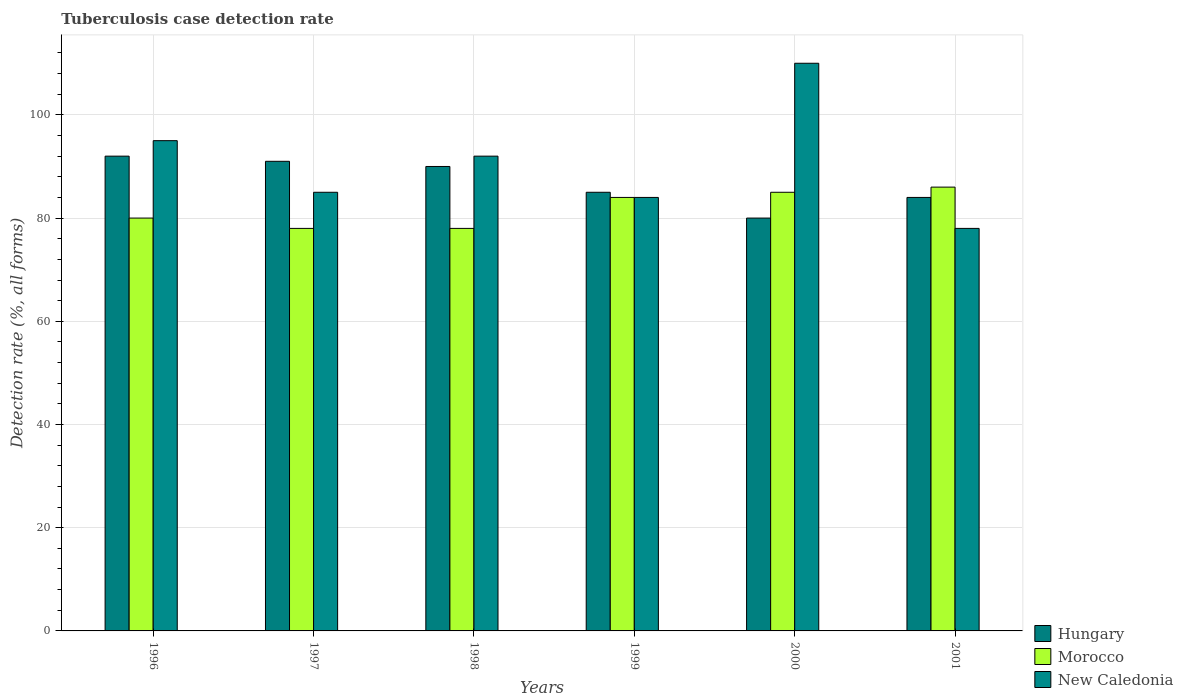How many groups of bars are there?
Make the answer very short. 6. Are the number of bars per tick equal to the number of legend labels?
Keep it short and to the point. Yes. How many bars are there on the 2nd tick from the left?
Provide a short and direct response. 3. What is the tuberculosis case detection rate in in Hungary in 1999?
Provide a short and direct response. 85. Across all years, what is the maximum tuberculosis case detection rate in in Hungary?
Your response must be concise. 92. Across all years, what is the minimum tuberculosis case detection rate in in Hungary?
Offer a very short reply. 80. What is the total tuberculosis case detection rate in in Morocco in the graph?
Your answer should be compact. 491. What is the difference between the tuberculosis case detection rate in in Hungary in 1996 and that in 1997?
Provide a short and direct response. 1. What is the average tuberculosis case detection rate in in Morocco per year?
Offer a very short reply. 81.83. In how many years, is the tuberculosis case detection rate in in Morocco greater than 64 %?
Your answer should be very brief. 6. What is the ratio of the tuberculosis case detection rate in in Morocco in 1998 to that in 2001?
Your answer should be compact. 0.91. Is the difference between the tuberculosis case detection rate in in New Caledonia in 1997 and 2000 greater than the difference between the tuberculosis case detection rate in in Hungary in 1997 and 2000?
Offer a terse response. No. What is the difference between the highest and the lowest tuberculosis case detection rate in in Morocco?
Provide a short and direct response. 8. In how many years, is the tuberculosis case detection rate in in Hungary greater than the average tuberculosis case detection rate in in Hungary taken over all years?
Provide a short and direct response. 3. Is the sum of the tuberculosis case detection rate in in Morocco in 1997 and 2000 greater than the maximum tuberculosis case detection rate in in New Caledonia across all years?
Your answer should be very brief. Yes. What does the 3rd bar from the left in 1996 represents?
Provide a short and direct response. New Caledonia. What does the 1st bar from the right in 1998 represents?
Offer a very short reply. New Caledonia. Are all the bars in the graph horizontal?
Provide a short and direct response. No. How many years are there in the graph?
Your response must be concise. 6. Does the graph contain any zero values?
Ensure brevity in your answer.  No. Where does the legend appear in the graph?
Give a very brief answer. Bottom right. How many legend labels are there?
Provide a succinct answer. 3. How are the legend labels stacked?
Keep it short and to the point. Vertical. What is the title of the graph?
Ensure brevity in your answer.  Tuberculosis case detection rate. What is the label or title of the Y-axis?
Keep it short and to the point. Detection rate (%, all forms). What is the Detection rate (%, all forms) in Hungary in 1996?
Your answer should be very brief. 92. What is the Detection rate (%, all forms) in New Caledonia in 1996?
Ensure brevity in your answer.  95. What is the Detection rate (%, all forms) of Hungary in 1997?
Offer a very short reply. 91. What is the Detection rate (%, all forms) in Morocco in 1997?
Offer a terse response. 78. What is the Detection rate (%, all forms) of New Caledonia in 1997?
Offer a terse response. 85. What is the Detection rate (%, all forms) of Hungary in 1998?
Ensure brevity in your answer.  90. What is the Detection rate (%, all forms) in Morocco in 1998?
Keep it short and to the point. 78. What is the Detection rate (%, all forms) in New Caledonia in 1998?
Your response must be concise. 92. What is the Detection rate (%, all forms) of Hungary in 1999?
Keep it short and to the point. 85. What is the Detection rate (%, all forms) of Morocco in 1999?
Offer a terse response. 84. What is the Detection rate (%, all forms) in New Caledonia in 1999?
Your answer should be very brief. 84. What is the Detection rate (%, all forms) of New Caledonia in 2000?
Make the answer very short. 110. What is the Detection rate (%, all forms) in Hungary in 2001?
Provide a short and direct response. 84. What is the Detection rate (%, all forms) in Morocco in 2001?
Offer a terse response. 86. Across all years, what is the maximum Detection rate (%, all forms) in Hungary?
Your answer should be compact. 92. Across all years, what is the maximum Detection rate (%, all forms) of Morocco?
Keep it short and to the point. 86. Across all years, what is the maximum Detection rate (%, all forms) in New Caledonia?
Make the answer very short. 110. Across all years, what is the minimum Detection rate (%, all forms) of Hungary?
Your answer should be very brief. 80. What is the total Detection rate (%, all forms) of Hungary in the graph?
Your answer should be compact. 522. What is the total Detection rate (%, all forms) of Morocco in the graph?
Your answer should be very brief. 491. What is the total Detection rate (%, all forms) of New Caledonia in the graph?
Keep it short and to the point. 544. What is the difference between the Detection rate (%, all forms) of Hungary in 1996 and that in 1997?
Offer a very short reply. 1. What is the difference between the Detection rate (%, all forms) of New Caledonia in 1996 and that in 1997?
Provide a short and direct response. 10. What is the difference between the Detection rate (%, all forms) in New Caledonia in 1996 and that in 1998?
Provide a short and direct response. 3. What is the difference between the Detection rate (%, all forms) in Morocco in 1996 and that in 1999?
Offer a very short reply. -4. What is the difference between the Detection rate (%, all forms) in New Caledonia in 1996 and that in 1999?
Your answer should be compact. 11. What is the difference between the Detection rate (%, all forms) in New Caledonia in 1996 and that in 2000?
Offer a terse response. -15. What is the difference between the Detection rate (%, all forms) in Hungary in 1996 and that in 2001?
Your response must be concise. 8. What is the difference between the Detection rate (%, all forms) in Morocco in 1996 and that in 2001?
Ensure brevity in your answer.  -6. What is the difference between the Detection rate (%, all forms) of New Caledonia in 1997 and that in 1998?
Your answer should be very brief. -7. What is the difference between the Detection rate (%, all forms) in Morocco in 1997 and that in 1999?
Keep it short and to the point. -6. What is the difference between the Detection rate (%, all forms) in New Caledonia in 1997 and that in 1999?
Offer a very short reply. 1. What is the difference between the Detection rate (%, all forms) of Hungary in 1997 and that in 2001?
Keep it short and to the point. 7. What is the difference between the Detection rate (%, all forms) in Morocco in 1998 and that in 1999?
Offer a terse response. -6. What is the difference between the Detection rate (%, all forms) in Hungary in 1998 and that in 2000?
Your answer should be very brief. 10. What is the difference between the Detection rate (%, all forms) of New Caledonia in 1998 and that in 2000?
Provide a short and direct response. -18. What is the difference between the Detection rate (%, all forms) in Morocco in 1999 and that in 2000?
Your response must be concise. -1. What is the difference between the Detection rate (%, all forms) in New Caledonia in 1999 and that in 2000?
Offer a very short reply. -26. What is the difference between the Detection rate (%, all forms) in Morocco in 1999 and that in 2001?
Offer a terse response. -2. What is the difference between the Detection rate (%, all forms) of Morocco in 1996 and the Detection rate (%, all forms) of New Caledonia in 1997?
Offer a very short reply. -5. What is the difference between the Detection rate (%, all forms) in Hungary in 1996 and the Detection rate (%, all forms) in Morocco in 1999?
Provide a short and direct response. 8. What is the difference between the Detection rate (%, all forms) of Hungary in 1996 and the Detection rate (%, all forms) of New Caledonia in 1999?
Your answer should be very brief. 8. What is the difference between the Detection rate (%, all forms) of Morocco in 1996 and the Detection rate (%, all forms) of New Caledonia in 1999?
Offer a terse response. -4. What is the difference between the Detection rate (%, all forms) in Hungary in 1996 and the Detection rate (%, all forms) in New Caledonia in 2000?
Your answer should be compact. -18. What is the difference between the Detection rate (%, all forms) in Morocco in 1996 and the Detection rate (%, all forms) in New Caledonia in 2000?
Keep it short and to the point. -30. What is the difference between the Detection rate (%, all forms) in Morocco in 1996 and the Detection rate (%, all forms) in New Caledonia in 2001?
Provide a succinct answer. 2. What is the difference between the Detection rate (%, all forms) in Hungary in 1997 and the Detection rate (%, all forms) in Morocco in 1998?
Offer a very short reply. 13. What is the difference between the Detection rate (%, all forms) in Hungary in 1997 and the Detection rate (%, all forms) in New Caledonia in 1998?
Your response must be concise. -1. What is the difference between the Detection rate (%, all forms) of Hungary in 1997 and the Detection rate (%, all forms) of Morocco in 1999?
Offer a very short reply. 7. What is the difference between the Detection rate (%, all forms) of Hungary in 1997 and the Detection rate (%, all forms) of New Caledonia in 1999?
Your response must be concise. 7. What is the difference between the Detection rate (%, all forms) in Morocco in 1997 and the Detection rate (%, all forms) in New Caledonia in 1999?
Your answer should be compact. -6. What is the difference between the Detection rate (%, all forms) of Hungary in 1997 and the Detection rate (%, all forms) of New Caledonia in 2000?
Your answer should be very brief. -19. What is the difference between the Detection rate (%, all forms) in Morocco in 1997 and the Detection rate (%, all forms) in New Caledonia in 2000?
Offer a terse response. -32. What is the difference between the Detection rate (%, all forms) of Morocco in 1998 and the Detection rate (%, all forms) of New Caledonia in 1999?
Keep it short and to the point. -6. What is the difference between the Detection rate (%, all forms) of Morocco in 1998 and the Detection rate (%, all forms) of New Caledonia in 2000?
Your answer should be compact. -32. What is the difference between the Detection rate (%, all forms) in Hungary in 1998 and the Detection rate (%, all forms) in Morocco in 2001?
Provide a succinct answer. 4. What is the difference between the Detection rate (%, all forms) of Morocco in 1998 and the Detection rate (%, all forms) of New Caledonia in 2001?
Give a very brief answer. 0. What is the difference between the Detection rate (%, all forms) of Morocco in 1999 and the Detection rate (%, all forms) of New Caledonia in 2000?
Make the answer very short. -26. What is the difference between the Detection rate (%, all forms) in Hungary in 1999 and the Detection rate (%, all forms) in New Caledonia in 2001?
Keep it short and to the point. 7. What is the difference between the Detection rate (%, all forms) in Morocco in 1999 and the Detection rate (%, all forms) in New Caledonia in 2001?
Keep it short and to the point. 6. What is the difference between the Detection rate (%, all forms) in Morocco in 2000 and the Detection rate (%, all forms) in New Caledonia in 2001?
Your answer should be very brief. 7. What is the average Detection rate (%, all forms) in Morocco per year?
Your response must be concise. 81.83. What is the average Detection rate (%, all forms) in New Caledonia per year?
Offer a terse response. 90.67. In the year 1997, what is the difference between the Detection rate (%, all forms) of Hungary and Detection rate (%, all forms) of Morocco?
Your answer should be compact. 13. In the year 1997, what is the difference between the Detection rate (%, all forms) of Hungary and Detection rate (%, all forms) of New Caledonia?
Your answer should be compact. 6. In the year 1997, what is the difference between the Detection rate (%, all forms) in Morocco and Detection rate (%, all forms) in New Caledonia?
Keep it short and to the point. -7. In the year 1998, what is the difference between the Detection rate (%, all forms) of Hungary and Detection rate (%, all forms) of New Caledonia?
Provide a short and direct response. -2. In the year 1998, what is the difference between the Detection rate (%, all forms) of Morocco and Detection rate (%, all forms) of New Caledonia?
Keep it short and to the point. -14. In the year 1999, what is the difference between the Detection rate (%, all forms) of Hungary and Detection rate (%, all forms) of New Caledonia?
Make the answer very short. 1. In the year 2000, what is the difference between the Detection rate (%, all forms) of Hungary and Detection rate (%, all forms) of Morocco?
Your answer should be compact. -5. In the year 2000, what is the difference between the Detection rate (%, all forms) of Hungary and Detection rate (%, all forms) of New Caledonia?
Your response must be concise. -30. In the year 2001, what is the difference between the Detection rate (%, all forms) in Morocco and Detection rate (%, all forms) in New Caledonia?
Your answer should be compact. 8. What is the ratio of the Detection rate (%, all forms) of Morocco in 1996 to that in 1997?
Make the answer very short. 1.03. What is the ratio of the Detection rate (%, all forms) in New Caledonia in 1996 to that in 1997?
Make the answer very short. 1.12. What is the ratio of the Detection rate (%, all forms) of Hungary in 1996 to that in 1998?
Offer a very short reply. 1.02. What is the ratio of the Detection rate (%, all forms) in Morocco in 1996 to that in 1998?
Give a very brief answer. 1.03. What is the ratio of the Detection rate (%, all forms) in New Caledonia in 1996 to that in 1998?
Offer a terse response. 1.03. What is the ratio of the Detection rate (%, all forms) of Hungary in 1996 to that in 1999?
Keep it short and to the point. 1.08. What is the ratio of the Detection rate (%, all forms) of Morocco in 1996 to that in 1999?
Provide a short and direct response. 0.95. What is the ratio of the Detection rate (%, all forms) of New Caledonia in 1996 to that in 1999?
Make the answer very short. 1.13. What is the ratio of the Detection rate (%, all forms) of Hungary in 1996 to that in 2000?
Give a very brief answer. 1.15. What is the ratio of the Detection rate (%, all forms) of New Caledonia in 1996 to that in 2000?
Your response must be concise. 0.86. What is the ratio of the Detection rate (%, all forms) in Hungary in 1996 to that in 2001?
Provide a succinct answer. 1.1. What is the ratio of the Detection rate (%, all forms) of Morocco in 1996 to that in 2001?
Offer a very short reply. 0.93. What is the ratio of the Detection rate (%, all forms) of New Caledonia in 1996 to that in 2001?
Give a very brief answer. 1.22. What is the ratio of the Detection rate (%, all forms) of Hungary in 1997 to that in 1998?
Offer a terse response. 1.01. What is the ratio of the Detection rate (%, all forms) of New Caledonia in 1997 to that in 1998?
Ensure brevity in your answer.  0.92. What is the ratio of the Detection rate (%, all forms) in Hungary in 1997 to that in 1999?
Your response must be concise. 1.07. What is the ratio of the Detection rate (%, all forms) of Morocco in 1997 to that in 1999?
Offer a terse response. 0.93. What is the ratio of the Detection rate (%, all forms) of New Caledonia in 1997 to that in 1999?
Provide a short and direct response. 1.01. What is the ratio of the Detection rate (%, all forms) of Hungary in 1997 to that in 2000?
Your response must be concise. 1.14. What is the ratio of the Detection rate (%, all forms) of Morocco in 1997 to that in 2000?
Your answer should be very brief. 0.92. What is the ratio of the Detection rate (%, all forms) of New Caledonia in 1997 to that in 2000?
Ensure brevity in your answer.  0.77. What is the ratio of the Detection rate (%, all forms) of Hungary in 1997 to that in 2001?
Your answer should be very brief. 1.08. What is the ratio of the Detection rate (%, all forms) of Morocco in 1997 to that in 2001?
Provide a succinct answer. 0.91. What is the ratio of the Detection rate (%, all forms) in New Caledonia in 1997 to that in 2001?
Ensure brevity in your answer.  1.09. What is the ratio of the Detection rate (%, all forms) of Hungary in 1998 to that in 1999?
Offer a very short reply. 1.06. What is the ratio of the Detection rate (%, all forms) in New Caledonia in 1998 to that in 1999?
Keep it short and to the point. 1.1. What is the ratio of the Detection rate (%, all forms) in Morocco in 1998 to that in 2000?
Your answer should be compact. 0.92. What is the ratio of the Detection rate (%, all forms) of New Caledonia in 1998 to that in 2000?
Provide a short and direct response. 0.84. What is the ratio of the Detection rate (%, all forms) of Hungary in 1998 to that in 2001?
Make the answer very short. 1.07. What is the ratio of the Detection rate (%, all forms) of Morocco in 1998 to that in 2001?
Provide a short and direct response. 0.91. What is the ratio of the Detection rate (%, all forms) in New Caledonia in 1998 to that in 2001?
Your answer should be compact. 1.18. What is the ratio of the Detection rate (%, all forms) in Hungary in 1999 to that in 2000?
Give a very brief answer. 1.06. What is the ratio of the Detection rate (%, all forms) in Morocco in 1999 to that in 2000?
Your answer should be compact. 0.99. What is the ratio of the Detection rate (%, all forms) in New Caledonia in 1999 to that in 2000?
Your answer should be compact. 0.76. What is the ratio of the Detection rate (%, all forms) of Hungary in 1999 to that in 2001?
Provide a short and direct response. 1.01. What is the ratio of the Detection rate (%, all forms) in Morocco in 1999 to that in 2001?
Your answer should be compact. 0.98. What is the ratio of the Detection rate (%, all forms) of New Caledonia in 1999 to that in 2001?
Ensure brevity in your answer.  1.08. What is the ratio of the Detection rate (%, all forms) of Hungary in 2000 to that in 2001?
Your answer should be very brief. 0.95. What is the ratio of the Detection rate (%, all forms) of Morocco in 2000 to that in 2001?
Give a very brief answer. 0.99. What is the ratio of the Detection rate (%, all forms) in New Caledonia in 2000 to that in 2001?
Keep it short and to the point. 1.41. What is the difference between the highest and the second highest Detection rate (%, all forms) of New Caledonia?
Offer a terse response. 15. What is the difference between the highest and the lowest Detection rate (%, all forms) in Hungary?
Give a very brief answer. 12. What is the difference between the highest and the lowest Detection rate (%, all forms) of New Caledonia?
Offer a very short reply. 32. 